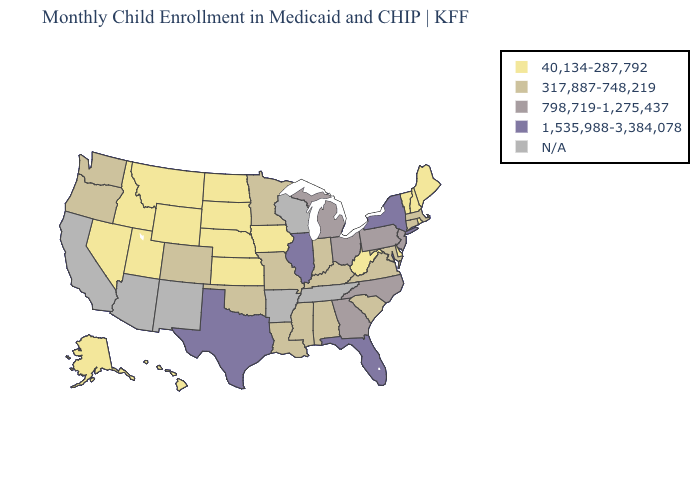What is the value of Colorado?
Write a very short answer. 317,887-748,219. What is the value of Washington?
Short answer required. 317,887-748,219. What is the highest value in states that border Tennessee?
Quick response, please. 798,719-1,275,437. Name the states that have a value in the range 317,887-748,219?
Be succinct. Alabama, Colorado, Connecticut, Indiana, Kentucky, Louisiana, Maryland, Massachusetts, Minnesota, Mississippi, Missouri, Oklahoma, Oregon, South Carolina, Virginia, Washington. What is the value of Kentucky?
Be succinct. 317,887-748,219. What is the value of California?
Keep it brief. N/A. What is the value of Georgia?
Keep it brief. 798,719-1,275,437. Among the states that border Connecticut , which have the highest value?
Concise answer only. New York. Does Indiana have the lowest value in the MidWest?
Answer briefly. No. Does Alaska have the highest value in the West?
Answer briefly. No. What is the value of Maine?
Answer briefly. 40,134-287,792. What is the highest value in the USA?
Answer briefly. 1,535,988-3,384,078. What is the highest value in the South ?
Answer briefly. 1,535,988-3,384,078. Which states have the highest value in the USA?
Quick response, please. Florida, Illinois, New York, Texas. 